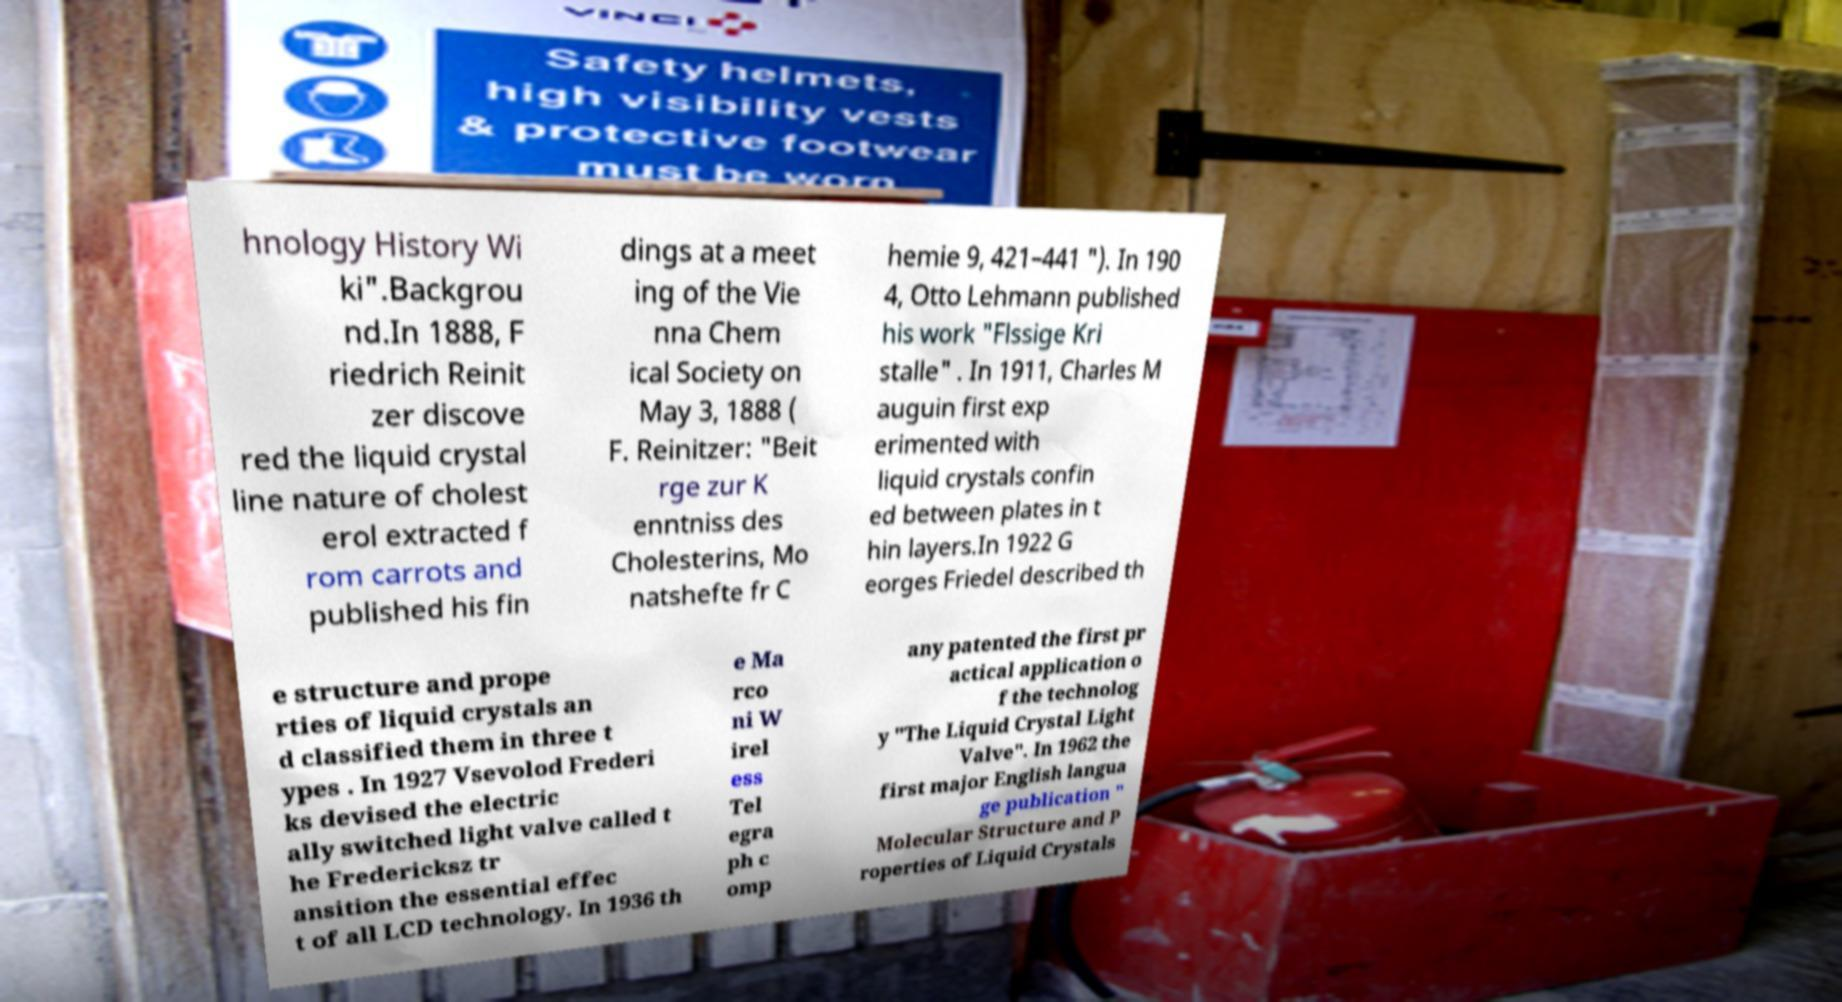Could you assist in decoding the text presented in this image and type it out clearly? hnology History Wi ki".Backgrou nd.In 1888, F riedrich Reinit zer discove red the liquid crystal line nature of cholest erol extracted f rom carrots and published his fin dings at a meet ing of the Vie nna Chem ical Society on May 3, 1888 ( F. Reinitzer: "Beit rge zur K enntniss des Cholesterins, Mo natshefte fr C hemie 9, 421–441 "). In 190 4, Otto Lehmann published his work "Flssige Kri stalle" . In 1911, Charles M auguin first exp erimented with liquid crystals confin ed between plates in t hin layers.In 1922 G eorges Friedel described th e structure and prope rties of liquid crystals an d classified them in three t ypes . In 1927 Vsevolod Frederi ks devised the electric ally switched light valve called t he Fredericksz tr ansition the essential effec t of all LCD technology. In 1936 th e Ma rco ni W irel ess Tel egra ph c omp any patented the first pr actical application o f the technolog y "The Liquid Crystal Light Valve". In 1962 the first major English langua ge publication " Molecular Structure and P roperties of Liquid Crystals 